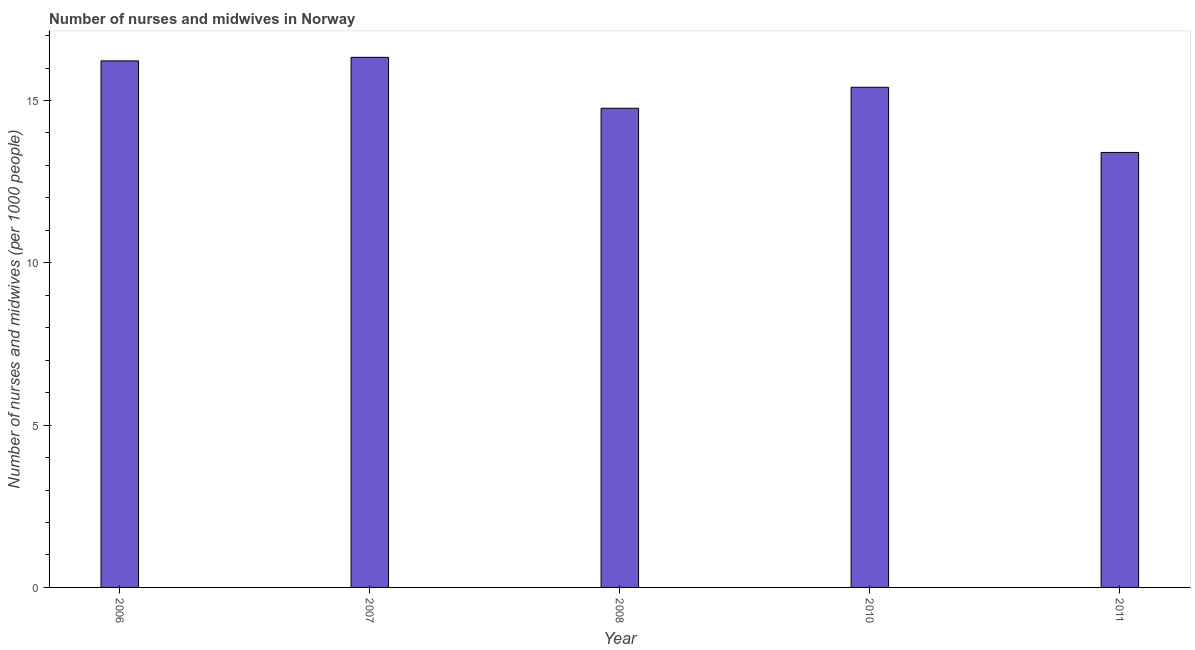Does the graph contain any zero values?
Provide a succinct answer. No. What is the title of the graph?
Make the answer very short. Number of nurses and midwives in Norway. What is the label or title of the X-axis?
Your response must be concise. Year. What is the label or title of the Y-axis?
Offer a very short reply. Number of nurses and midwives (per 1000 people). What is the number of nurses and midwives in 2007?
Keep it short and to the point. 16.33. Across all years, what is the maximum number of nurses and midwives?
Keep it short and to the point. 16.33. Across all years, what is the minimum number of nurses and midwives?
Your answer should be compact. 13.4. In which year was the number of nurses and midwives maximum?
Keep it short and to the point. 2007. What is the sum of the number of nurses and midwives?
Your response must be concise. 76.11. What is the difference between the number of nurses and midwives in 2007 and 2008?
Your response must be concise. 1.57. What is the average number of nurses and midwives per year?
Keep it short and to the point. 15.22. What is the median number of nurses and midwives?
Keep it short and to the point. 15.41. In how many years, is the number of nurses and midwives greater than 9 ?
Ensure brevity in your answer.  5. Do a majority of the years between 2006 and 2007 (inclusive) have number of nurses and midwives greater than 12 ?
Offer a very short reply. Yes. What is the ratio of the number of nurses and midwives in 2006 to that in 2008?
Offer a very short reply. 1.1. What is the difference between the highest and the second highest number of nurses and midwives?
Your response must be concise. 0.11. What is the difference between the highest and the lowest number of nurses and midwives?
Make the answer very short. 2.93. In how many years, is the number of nurses and midwives greater than the average number of nurses and midwives taken over all years?
Keep it short and to the point. 3. How many bars are there?
Your response must be concise. 5. Are all the bars in the graph horizontal?
Your answer should be very brief. No. What is the difference between two consecutive major ticks on the Y-axis?
Your answer should be compact. 5. Are the values on the major ticks of Y-axis written in scientific E-notation?
Keep it short and to the point. No. What is the Number of nurses and midwives (per 1000 people) of 2006?
Ensure brevity in your answer.  16.22. What is the Number of nurses and midwives (per 1000 people) in 2007?
Offer a terse response. 16.33. What is the Number of nurses and midwives (per 1000 people) of 2008?
Keep it short and to the point. 14.76. What is the Number of nurses and midwives (per 1000 people) in 2010?
Provide a succinct answer. 15.41. What is the Number of nurses and midwives (per 1000 people) of 2011?
Offer a very short reply. 13.4. What is the difference between the Number of nurses and midwives (per 1000 people) in 2006 and 2007?
Give a very brief answer. -0.11. What is the difference between the Number of nurses and midwives (per 1000 people) in 2006 and 2008?
Provide a succinct answer. 1.46. What is the difference between the Number of nurses and midwives (per 1000 people) in 2006 and 2010?
Offer a very short reply. 0.81. What is the difference between the Number of nurses and midwives (per 1000 people) in 2006 and 2011?
Ensure brevity in your answer.  2.82. What is the difference between the Number of nurses and midwives (per 1000 people) in 2007 and 2008?
Ensure brevity in your answer.  1.57. What is the difference between the Number of nurses and midwives (per 1000 people) in 2007 and 2010?
Your answer should be compact. 0.92. What is the difference between the Number of nurses and midwives (per 1000 people) in 2007 and 2011?
Your answer should be compact. 2.93. What is the difference between the Number of nurses and midwives (per 1000 people) in 2008 and 2010?
Your response must be concise. -0.65. What is the difference between the Number of nurses and midwives (per 1000 people) in 2008 and 2011?
Offer a terse response. 1.36. What is the difference between the Number of nurses and midwives (per 1000 people) in 2010 and 2011?
Provide a succinct answer. 2.01. What is the ratio of the Number of nurses and midwives (per 1000 people) in 2006 to that in 2007?
Keep it short and to the point. 0.99. What is the ratio of the Number of nurses and midwives (per 1000 people) in 2006 to that in 2008?
Provide a short and direct response. 1.1. What is the ratio of the Number of nurses and midwives (per 1000 people) in 2006 to that in 2010?
Your answer should be very brief. 1.05. What is the ratio of the Number of nurses and midwives (per 1000 people) in 2006 to that in 2011?
Your answer should be compact. 1.21. What is the ratio of the Number of nurses and midwives (per 1000 people) in 2007 to that in 2008?
Offer a terse response. 1.11. What is the ratio of the Number of nurses and midwives (per 1000 people) in 2007 to that in 2010?
Ensure brevity in your answer.  1.06. What is the ratio of the Number of nurses and midwives (per 1000 people) in 2007 to that in 2011?
Offer a terse response. 1.22. What is the ratio of the Number of nurses and midwives (per 1000 people) in 2008 to that in 2010?
Your answer should be compact. 0.96. What is the ratio of the Number of nurses and midwives (per 1000 people) in 2008 to that in 2011?
Offer a very short reply. 1.1. What is the ratio of the Number of nurses and midwives (per 1000 people) in 2010 to that in 2011?
Make the answer very short. 1.15. 